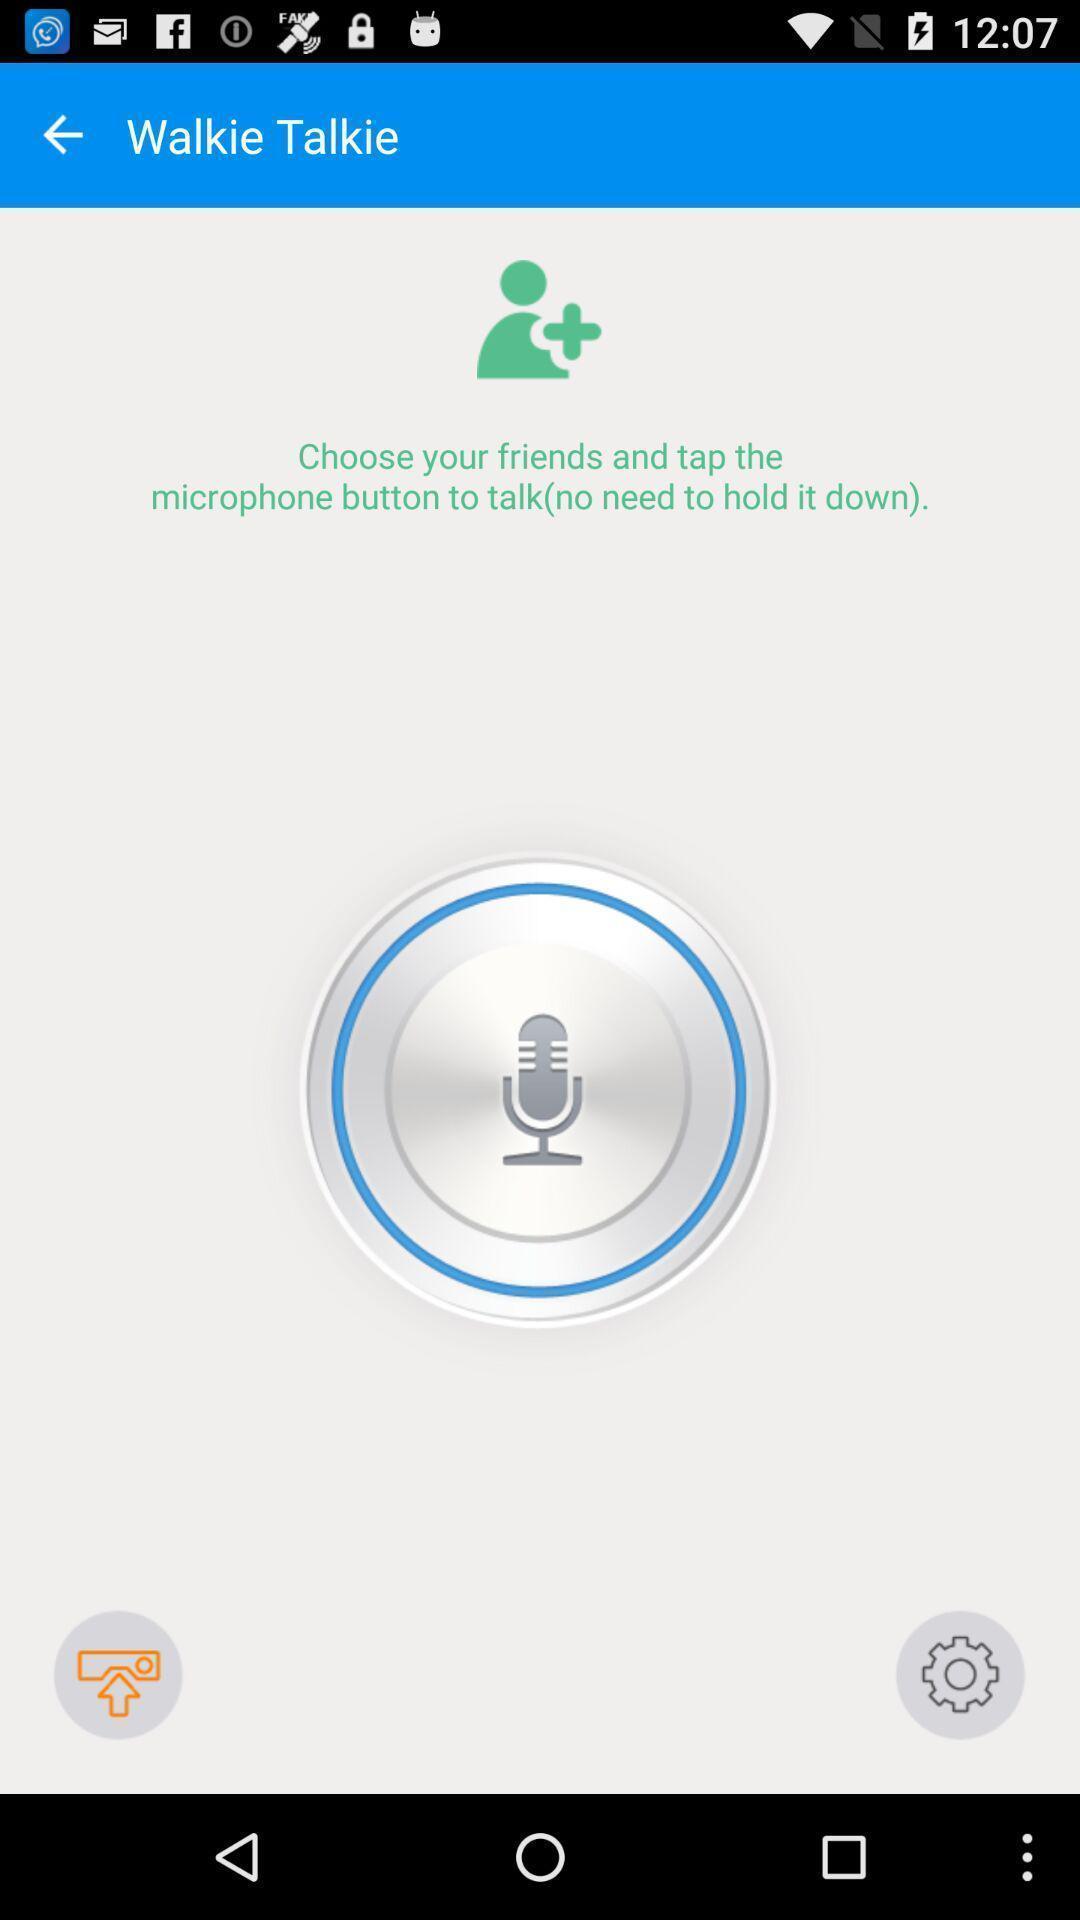Describe the key features of this screenshot. Screen showing add friend option in social app. 